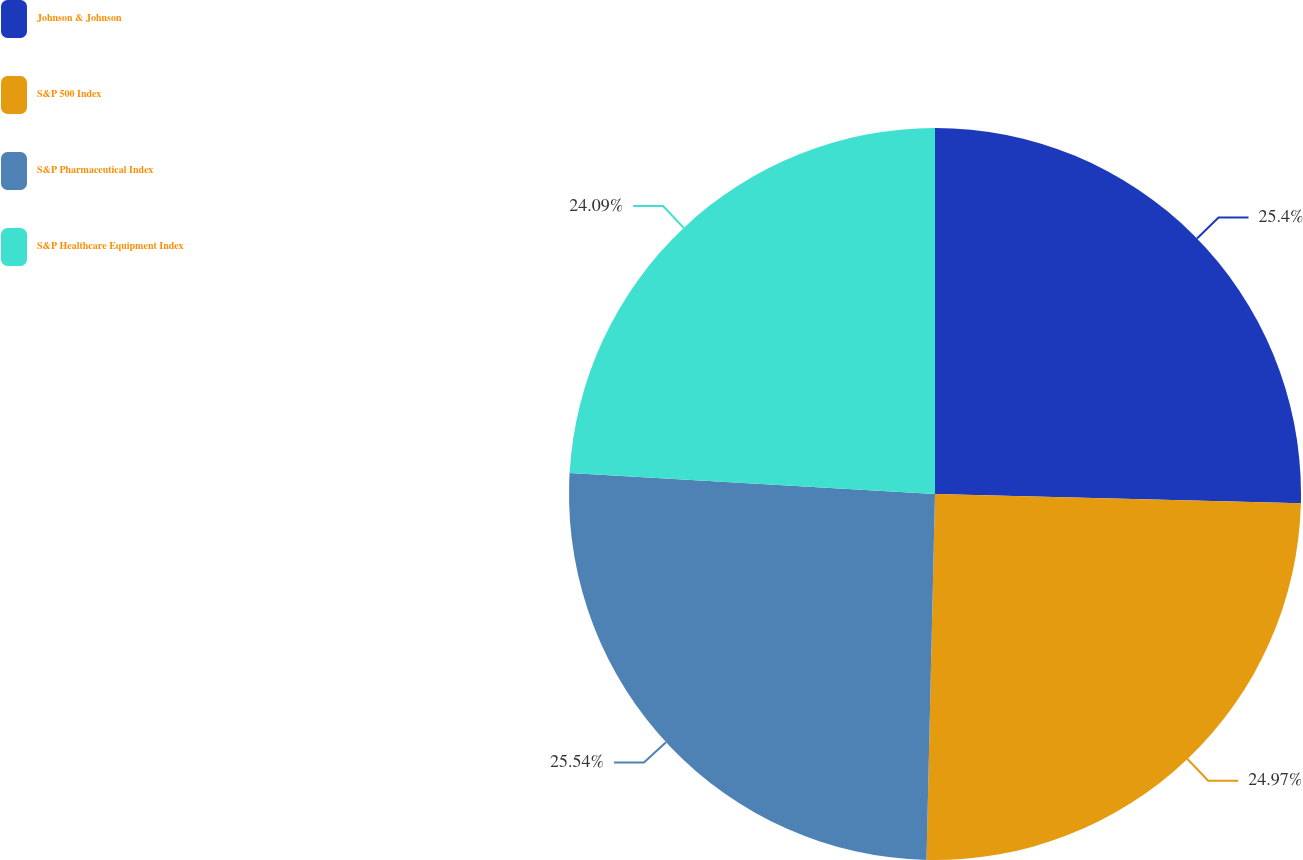Convert chart. <chart><loc_0><loc_0><loc_500><loc_500><pie_chart><fcel>Johnson & Johnson<fcel>S&P 500 Index<fcel>S&P Pharmaceutical Index<fcel>S&P Healthcare Equipment Index<nl><fcel>25.4%<fcel>24.97%<fcel>25.54%<fcel>24.09%<nl></chart> 